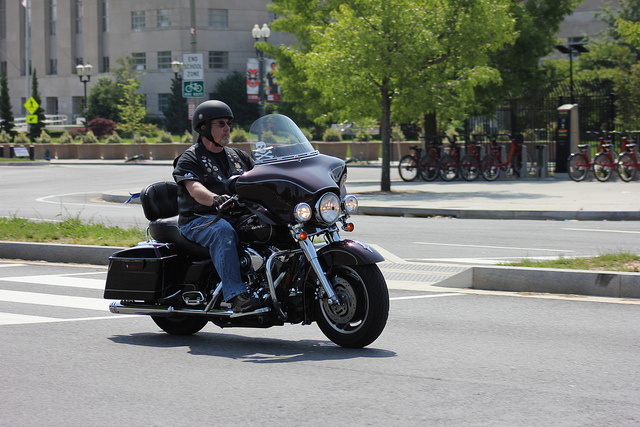<image>Does the rider enjoy riding motorcycles? It's ambiguous whether the rider enjoys riding motorcycles or not. Does the rider enjoy riding motorcycles? I don't know if the rider enjoys riding motorcycles. 